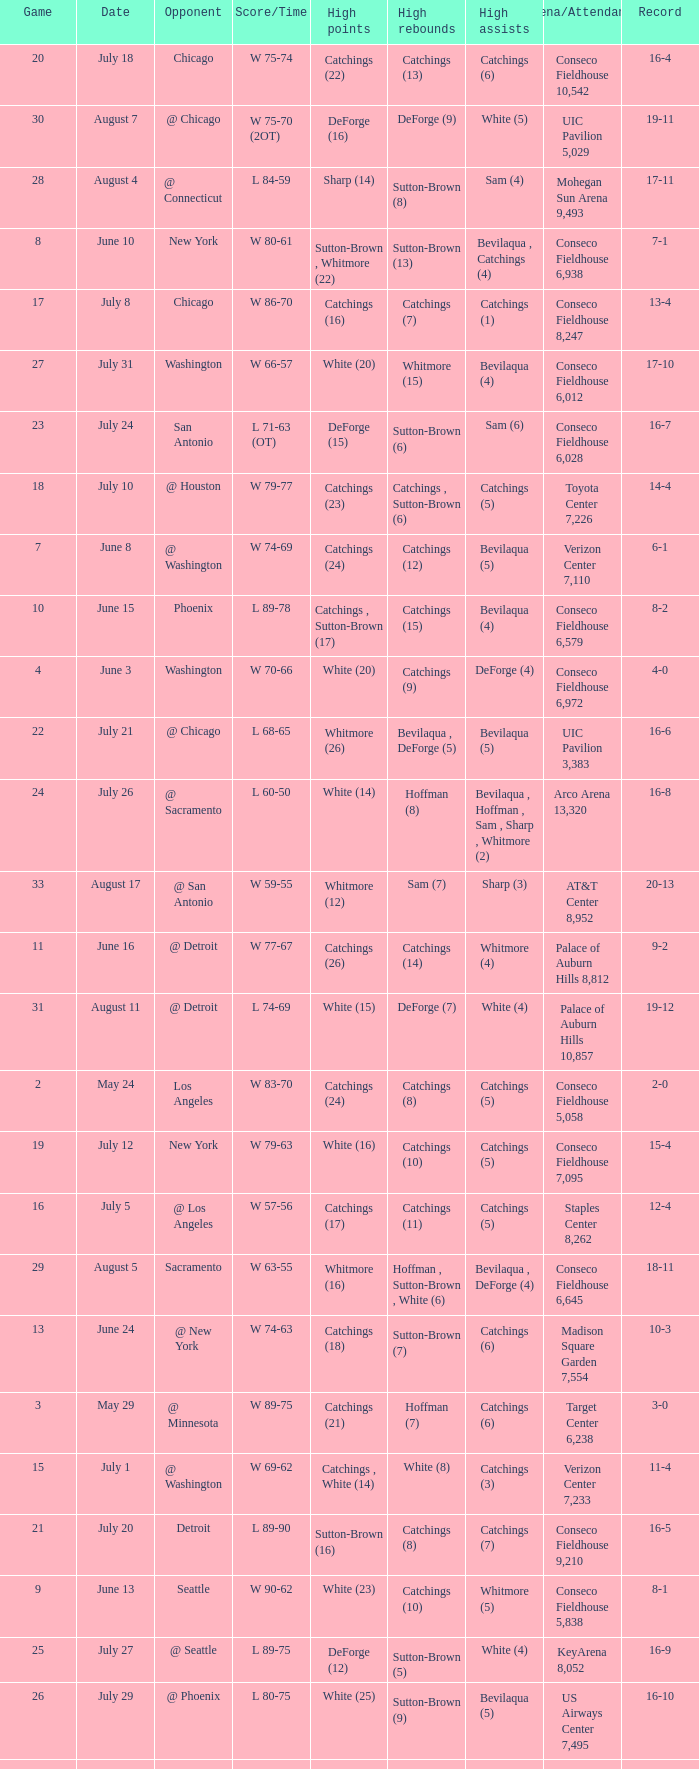Help me parse the entirety of this table. {'header': ['Game', 'Date', 'Opponent', 'Score/Time', 'High points', 'High rebounds', 'High assists', 'Arena/Attendance', 'Record'], 'rows': [['20', 'July 18', 'Chicago', 'W 75-74', 'Catchings (22)', 'Catchings (13)', 'Catchings (6)', 'Conseco Fieldhouse 10,542', '16-4'], ['30', 'August 7', '@ Chicago', 'W 75-70 (2OT)', 'DeForge (16)', 'DeForge (9)', 'White (5)', 'UIC Pavilion 5,029', '19-11'], ['28', 'August 4', '@ Connecticut', 'L 84-59', 'Sharp (14)', 'Sutton-Brown (8)', 'Sam (4)', 'Mohegan Sun Arena 9,493', '17-11'], ['8', 'June 10', 'New York', 'W 80-61', 'Sutton-Brown , Whitmore (22)', 'Sutton-Brown (13)', 'Bevilaqua , Catchings (4)', 'Conseco Fieldhouse 6,938', '7-1'], ['17', 'July 8', 'Chicago', 'W 86-70', 'Catchings (16)', 'Catchings (7)', 'Catchings (1)', 'Conseco Fieldhouse 8,247', '13-4'], ['27', 'July 31', 'Washington', 'W 66-57', 'White (20)', 'Whitmore (15)', 'Bevilaqua (4)', 'Conseco Fieldhouse 6,012', '17-10'], ['23', 'July 24', 'San Antonio', 'L 71-63 (OT)', 'DeForge (15)', 'Sutton-Brown (6)', 'Sam (6)', 'Conseco Fieldhouse 6,028', '16-7'], ['18', 'July 10', '@ Houston', 'W 79-77', 'Catchings (23)', 'Catchings , Sutton-Brown (6)', 'Catchings (5)', 'Toyota Center 7,226', '14-4'], ['7', 'June 8', '@ Washington', 'W 74-69', 'Catchings (24)', 'Catchings (12)', 'Bevilaqua (5)', 'Verizon Center 7,110', '6-1'], ['10', 'June 15', 'Phoenix', 'L 89-78', 'Catchings , Sutton-Brown (17)', 'Catchings (15)', 'Bevilaqua (4)', 'Conseco Fieldhouse 6,579', '8-2'], ['4', 'June 3', 'Washington', 'W 70-66', 'White (20)', 'Catchings (9)', 'DeForge (4)', 'Conseco Fieldhouse 6,972', '4-0'], ['22', 'July 21', '@ Chicago', 'L 68-65', 'Whitmore (26)', 'Bevilaqua , DeForge (5)', 'Bevilaqua (5)', 'UIC Pavilion 3,383', '16-6'], ['24', 'July 26', '@ Sacramento', 'L 60-50', 'White (14)', 'Hoffman (8)', 'Bevilaqua , Hoffman , Sam , Sharp , Whitmore (2)', 'Arco Arena 13,320', '16-8'], ['33', 'August 17', '@ San Antonio', 'W 59-55', 'Whitmore (12)', 'Sam (7)', 'Sharp (3)', 'AT&T Center 8,952', '20-13'], ['11', 'June 16', '@ Detroit', 'W 77-67', 'Catchings (26)', 'Catchings (14)', 'Whitmore (4)', 'Palace of Auburn Hills 8,812', '9-2'], ['31', 'August 11', '@ Detroit', 'L 74-69', 'White (15)', 'DeForge (7)', 'White (4)', 'Palace of Auburn Hills 10,857', '19-12'], ['2', 'May 24', 'Los Angeles', 'W 83-70', 'Catchings (24)', 'Catchings (8)', 'Catchings (5)', 'Conseco Fieldhouse 5,058', '2-0'], ['19', 'July 12', 'New York', 'W 79-63', 'White (16)', 'Catchings (10)', 'Catchings (5)', 'Conseco Fieldhouse 7,095', '15-4'], ['16', 'July 5', '@ Los Angeles', 'W 57-56', 'Catchings (17)', 'Catchings (11)', 'Catchings (5)', 'Staples Center 8,262', '12-4'], ['29', 'August 5', 'Sacramento', 'W 63-55', 'Whitmore (16)', 'Hoffman , Sutton-Brown , White (6)', 'Bevilaqua , DeForge (4)', 'Conseco Fieldhouse 6,645', '18-11'], ['13', 'June 24', '@ New York', 'W 74-63', 'Catchings (18)', 'Sutton-Brown (7)', 'Catchings (6)', 'Madison Square Garden 7,554', '10-3'], ['3', 'May 29', '@ Minnesota', 'W 89-75', 'Catchings (21)', 'Hoffman (7)', 'Catchings (6)', 'Target Center 6,238', '3-0'], ['15', 'July 1', '@ Washington', 'W 69-62', 'Catchings , White (14)', 'White (8)', 'Catchings (3)', 'Verizon Center 7,233', '11-4'], ['21', 'July 20', 'Detroit', 'L 89-90', 'Sutton-Brown (16)', 'Catchings (8)', 'Catchings (7)', 'Conseco Fieldhouse 9,210', '16-5'], ['9', 'June 13', 'Seattle', 'W 90-62', 'White (23)', 'Catchings (10)', 'Whitmore (5)', 'Conseco Fieldhouse 5,838', '8-1'], ['25', 'July 27', '@ Seattle', 'L 89-75', 'DeForge (12)', 'Sutton-Brown (5)', 'White (4)', 'KeyArena 8,052', '16-9'], ['26', 'July 29', '@ Phoenix', 'L 80-75', 'White (25)', 'Sutton-Brown (9)', 'Bevilaqua (5)', 'US Airways Center 7,495', '16-10'], ['12', 'June 22', 'Connecticut', 'L 78-74', 'White , Whitmore (15)', 'Catchings (12)', 'Catchings (7)', 'Conseco Fieldhouse 7,240', '9-3'], ['6', 'June 6', 'Houston', 'W 84-59', 'Sutton-Brown (17)', 'Catchings (7)', 'Sharp (6)', 'Conseco Fieldhouse 5,909', '5-1'], ['32', 'August 15', 'Connecticut', 'L 77-74', 'DeForge (29)', 'Sutton-Brown (10)', 'White (4)', 'Conseco Fieldhouse 6,433', '19-13'], ['14', 'June 29', '@ Connecticut', 'L 72-67', 'Whitmore (13)', 'Catchings (11)', 'Sutton-Brown (5)', 'Mohegan Sun Arena 7,617', '10-4'], ['5', 'June 5', '@ New York', 'L 78-67', 'Catchings (21)', 'Whitmore (8)', 'Catchings (9)', 'Madison Square Garden 7,282', '4-1'], ['1', 'May 19', 'Minnesota', 'W 83-64', 'White (17)', 'Catchings (7)', 'Catchings (4)', 'Conseco Fieldhouse 9,210', '1-0']]} Name the total number of opponent of record 9-2 1.0. 